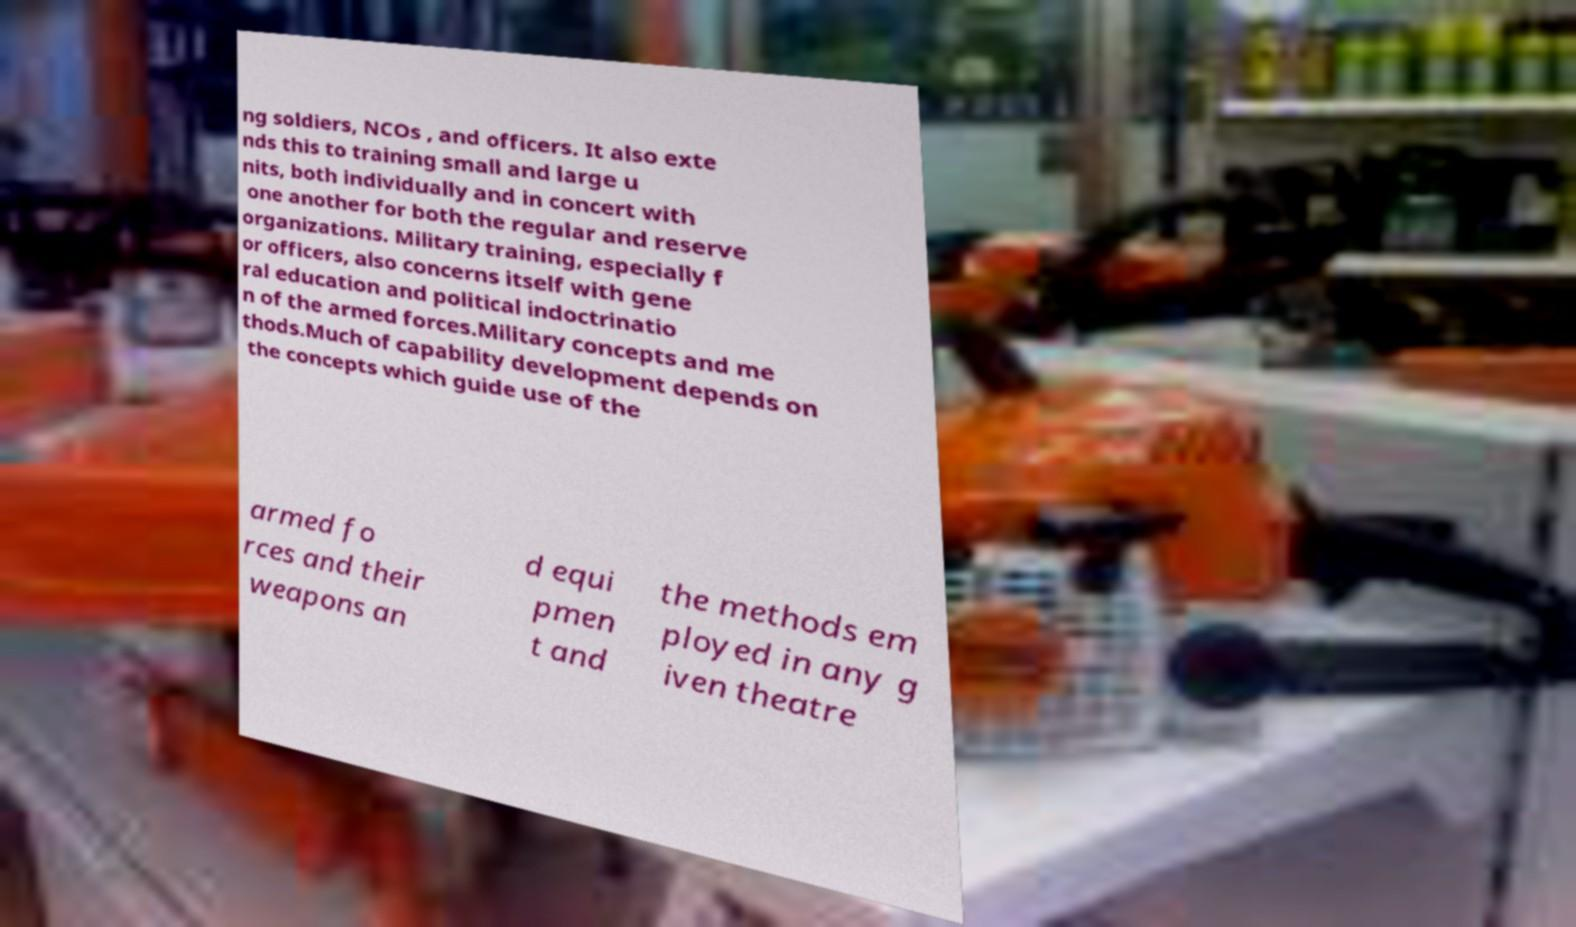Please read and relay the text visible in this image. What does it say? ng soldiers, NCOs , and officers. It also exte nds this to training small and large u nits, both individually and in concert with one another for both the regular and reserve organizations. Military training, especially f or officers, also concerns itself with gene ral education and political indoctrinatio n of the armed forces.Military concepts and me thods.Much of capability development depends on the concepts which guide use of the armed fo rces and their weapons an d equi pmen t and the methods em ployed in any g iven theatre 